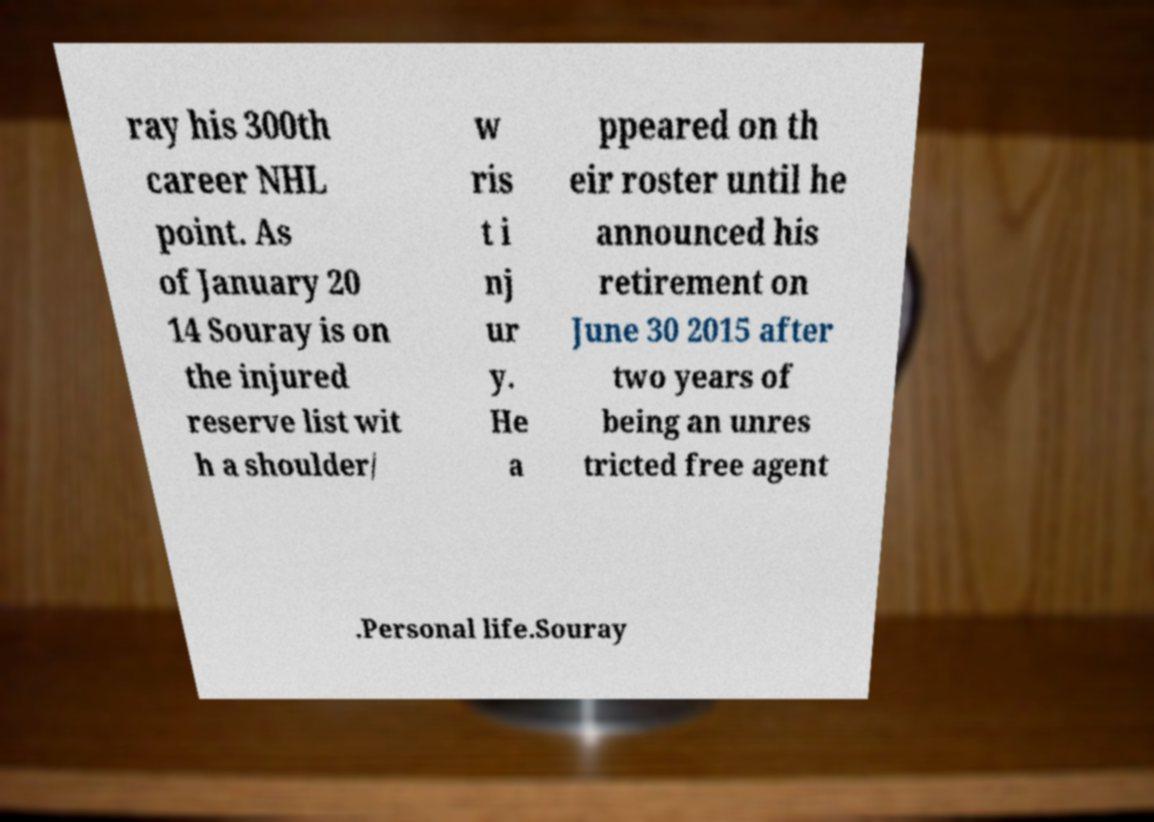I need the written content from this picture converted into text. Can you do that? ray his 300th career NHL point. As of January 20 14 Souray is on the injured reserve list wit h a shoulder/ w ris t i nj ur y. He a ppeared on th eir roster until he announced his retirement on June 30 2015 after two years of being an unres tricted free agent .Personal life.Souray 